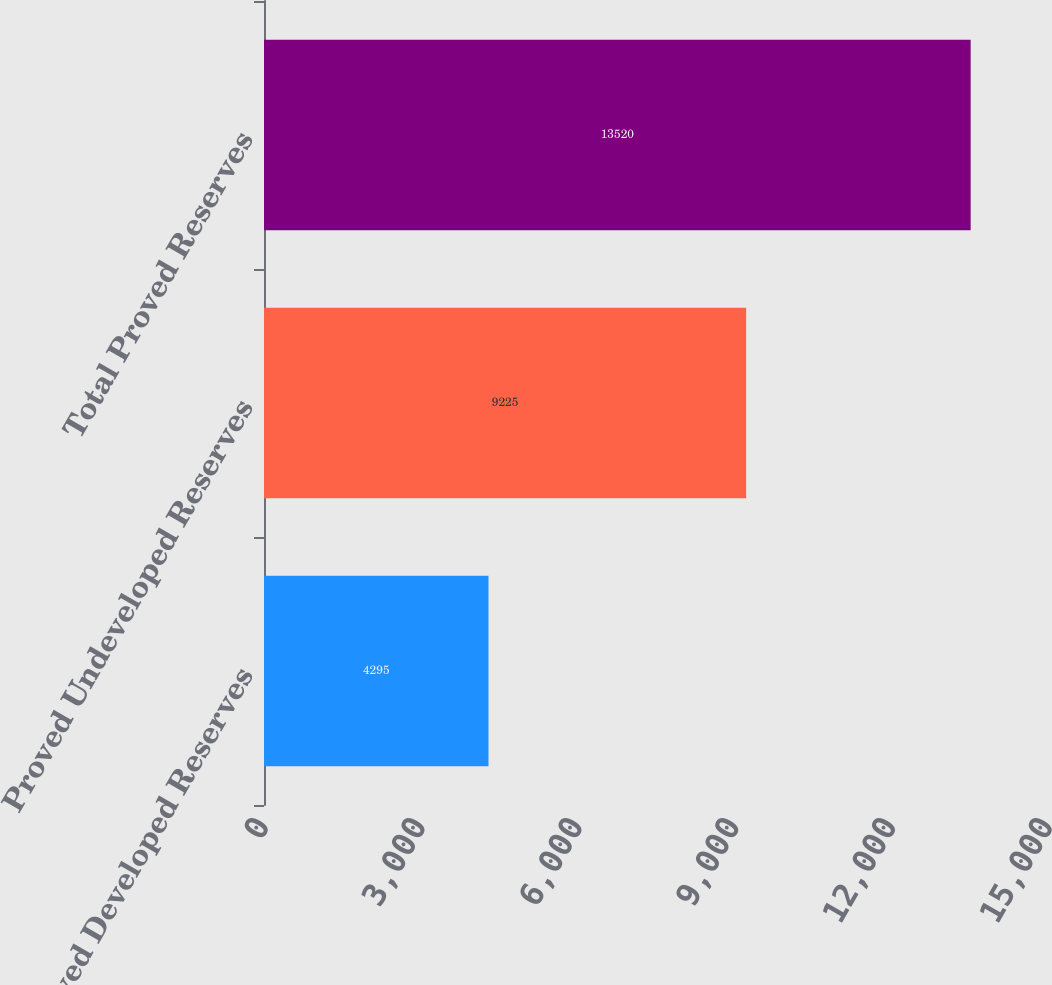Convert chart to OTSL. <chart><loc_0><loc_0><loc_500><loc_500><bar_chart><fcel>Proved Developed Reserves<fcel>Proved Undeveloped Reserves<fcel>Total Proved Reserves<nl><fcel>4295<fcel>9225<fcel>13520<nl></chart> 